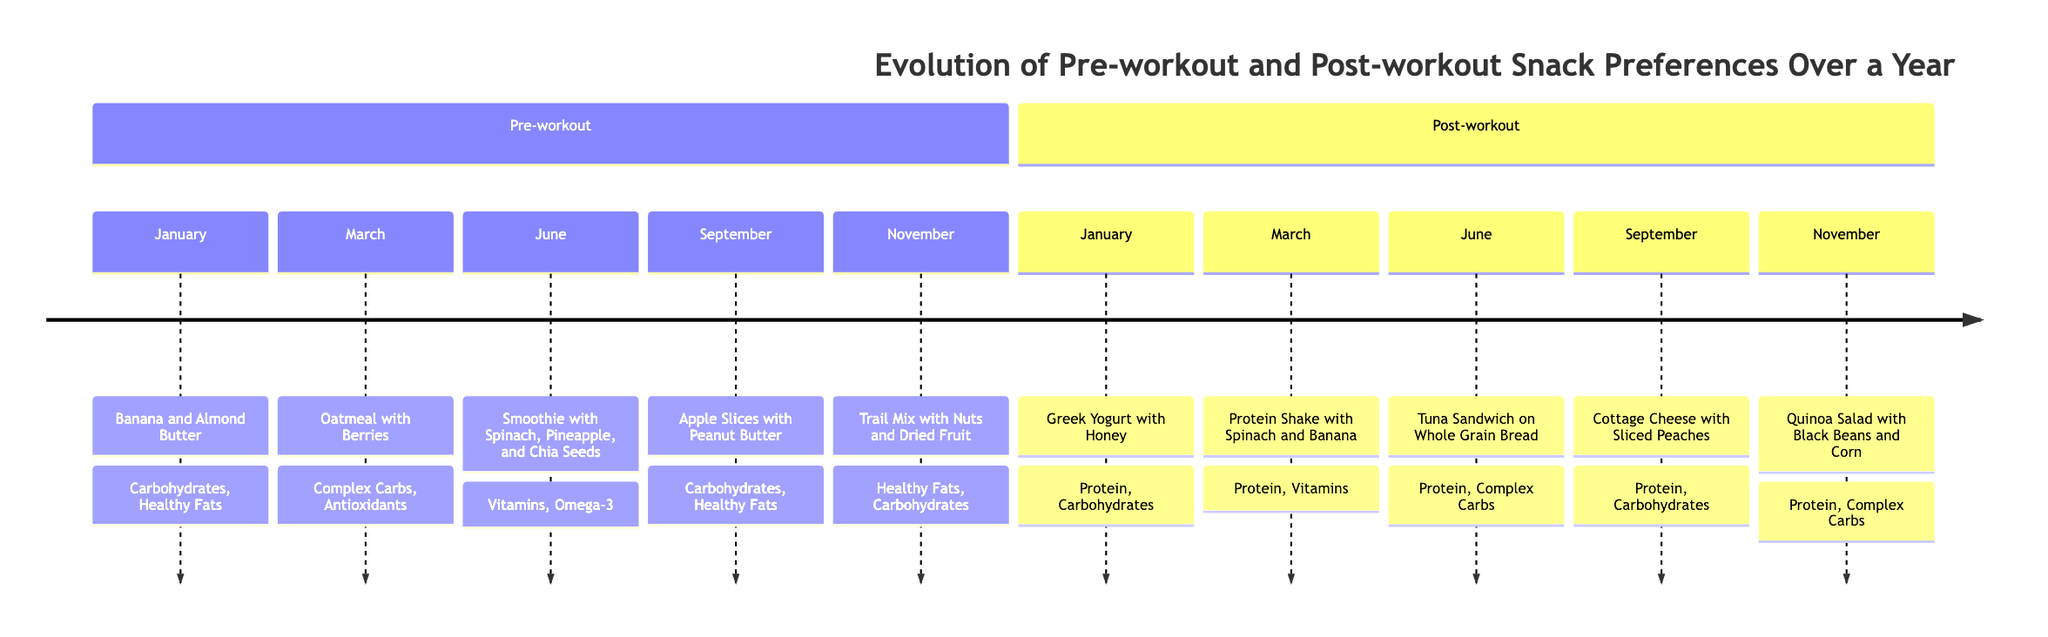What is the pre-workout snack for June? The diagram indicates that the pre-workout snack for June is a "Smoothie with Spinach, Pineapple, and Chia Seeds."
Answer: Smoothie with Spinach, Pineapple, and Chia Seeds How many different pre-workout snacks are listed? By counting the unique snacks mentioned for each month in the pre-workout section, we find five: Banana and Almond Butter, Oatmeal with Berries, Smoothie with Spinach, Apple Slices with Peanut Butter, and Trail Mix.
Answer: 5 What nutrients are included in the post-workout snack for September? Referring to the post-workout section for September, the nutrients for the snack "Cottage Cheese with Sliced Peaches" are "Protein, Carbohydrates."
Answer: Protein, Carbohydrates Which pre-workout snack has healthy fats listed as a nutrient? Looking through the pre-workout snacks, the ones that include healthy fats are "Banana and Almond Butter," "Apple Slices with Peanut Butter," and "Trail Mix with Nuts and Dried Fruit." The question seeks any one of them, and the earliest one listed is "Banana and Almond Butter."
Answer: Banana and Almond Butter Which post-workout snack includes complex carbohydrates? In the post-workout section, the snack "Tuna Sandwich on Whole Grain Bread" and "Quinoa Salad with Black Beans and Corn" are both noted to have complex carbohydrates, but we need to identify any one of them. The earliest is "Tuna Sandwich on Whole Grain Bread."
Answer: Tuna Sandwich on Whole Grain Bread 